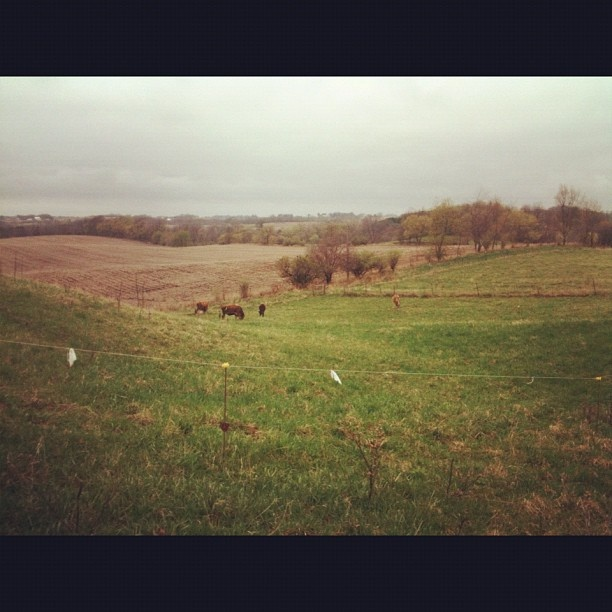Describe the objects in this image and their specific colors. I can see cow in black, maroon, gray, and brown tones, cow in black, maroon, gray, and brown tones, bird in black, tan, and gray tones, bird in black, beige, olive, and tan tones, and cow in black, maroon, olive, gray, and tan tones in this image. 